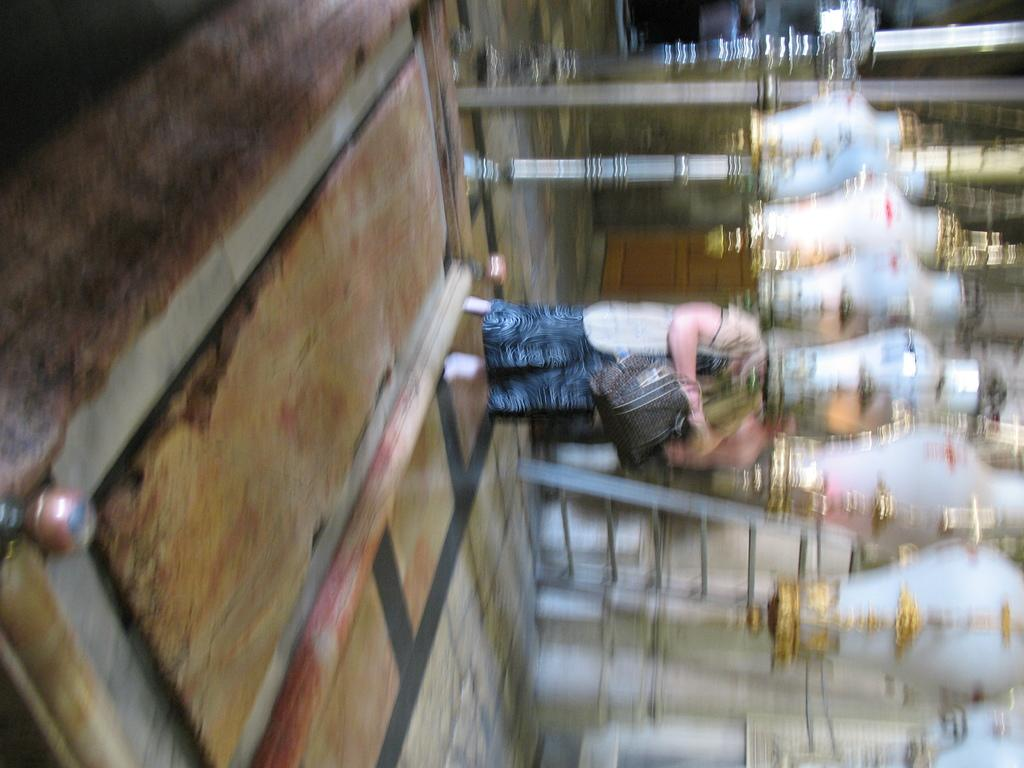What is the overall quality of the image? The image is blurred. Can you identify any human presence in the image? Yes, there is a person standing in the image. What color and location of objects can be seen in the image? There are white color objects on the right side of the image. What type of nerve is visible in the image? There is no nerve visible in the image; it is a blurred image of a person and white objects. How many daughters can be seen in the image? There is no daughter present in the image; it only features a person and white objects. 